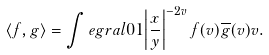Convert formula to latex. <formula><loc_0><loc_0><loc_500><loc_500>\langle f , g \rangle = \int e g r a l { 0 } { 1 } { \left | \frac { x } { y } \right | ^ { - 2 v } f ( v ) \overline { g } ( v ) } { v } .</formula> 